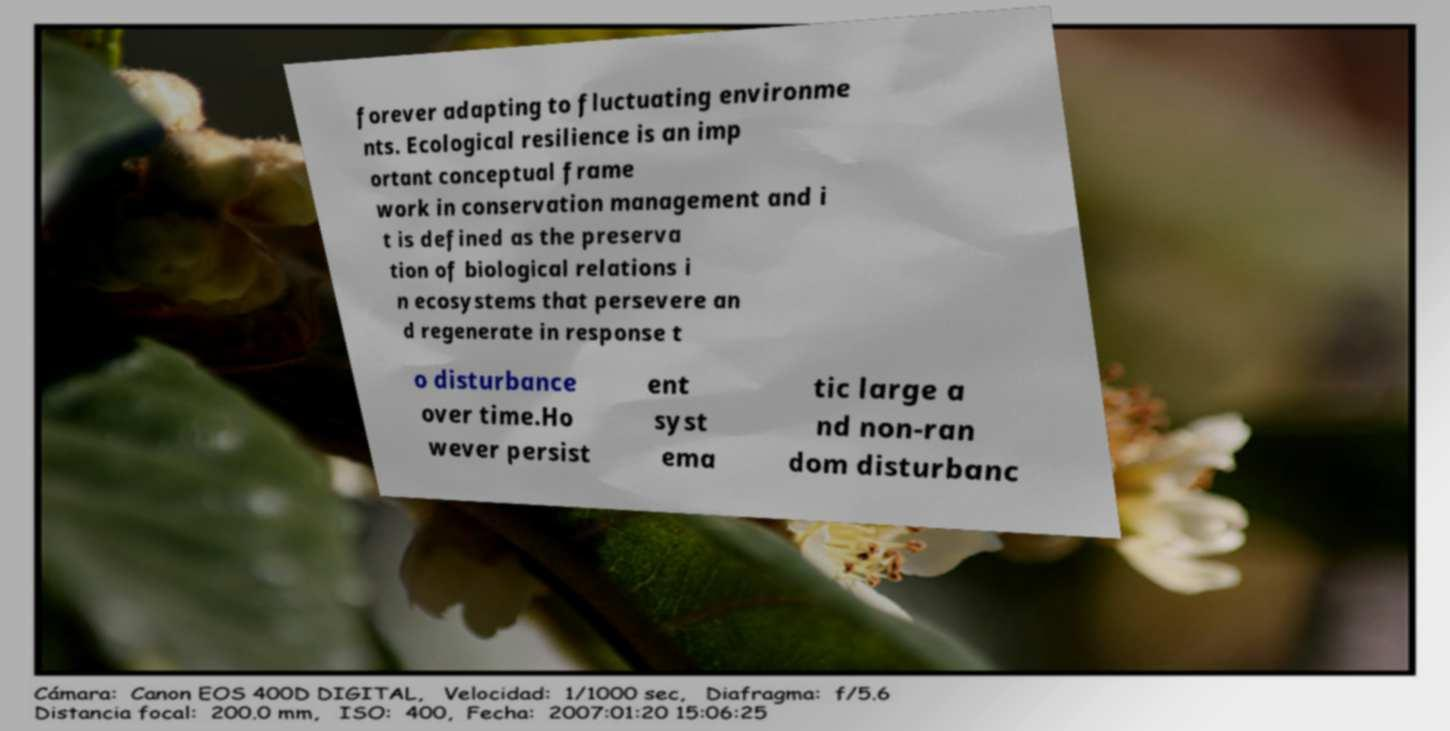Could you extract and type out the text from this image? forever adapting to fluctuating environme nts. Ecological resilience is an imp ortant conceptual frame work in conservation management and i t is defined as the preserva tion of biological relations i n ecosystems that persevere an d regenerate in response t o disturbance over time.Ho wever persist ent syst ema tic large a nd non-ran dom disturbanc 